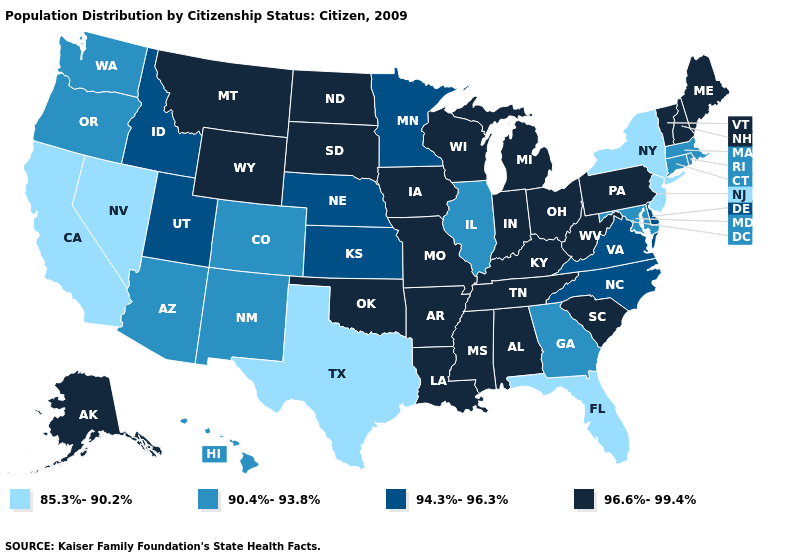Name the states that have a value in the range 96.6%-99.4%?
Keep it brief. Alabama, Alaska, Arkansas, Indiana, Iowa, Kentucky, Louisiana, Maine, Michigan, Mississippi, Missouri, Montana, New Hampshire, North Dakota, Ohio, Oklahoma, Pennsylvania, South Carolina, South Dakota, Tennessee, Vermont, West Virginia, Wisconsin, Wyoming. What is the lowest value in the USA?
Write a very short answer. 85.3%-90.2%. Name the states that have a value in the range 94.3%-96.3%?
Keep it brief. Delaware, Idaho, Kansas, Minnesota, Nebraska, North Carolina, Utah, Virginia. Among the states that border Florida , does Georgia have the lowest value?
Keep it brief. Yes. Name the states that have a value in the range 94.3%-96.3%?
Quick response, please. Delaware, Idaho, Kansas, Minnesota, Nebraska, North Carolina, Utah, Virginia. Does the first symbol in the legend represent the smallest category?
Quick response, please. Yes. What is the value of South Dakota?
Be succinct. 96.6%-99.4%. What is the value of Maryland?
Quick response, please. 90.4%-93.8%. Which states have the lowest value in the MidWest?
Keep it brief. Illinois. Is the legend a continuous bar?
Concise answer only. No. Which states hav the highest value in the South?
Concise answer only. Alabama, Arkansas, Kentucky, Louisiana, Mississippi, Oklahoma, South Carolina, Tennessee, West Virginia. Which states hav the highest value in the MidWest?
Be succinct. Indiana, Iowa, Michigan, Missouri, North Dakota, Ohio, South Dakota, Wisconsin. What is the highest value in the USA?
Be succinct. 96.6%-99.4%. What is the value of Idaho?
Short answer required. 94.3%-96.3%. Among the states that border Montana , does Idaho have the highest value?
Short answer required. No. 